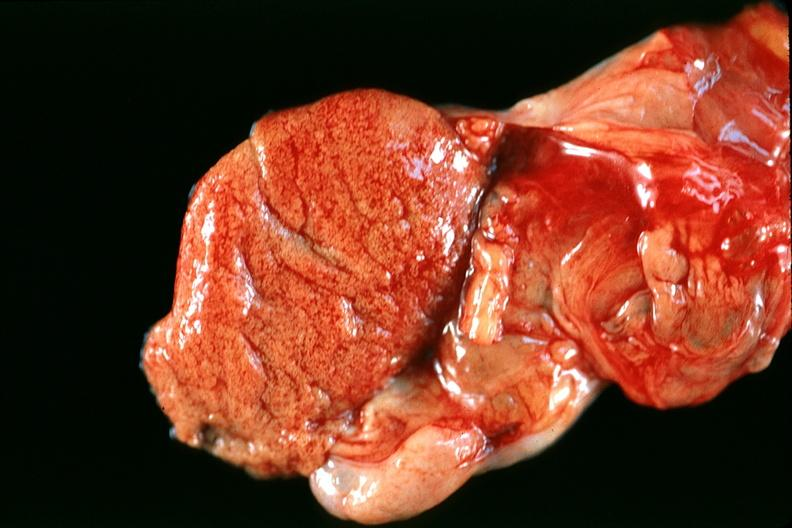what is present?
Answer the question using a single word or phrase. Male reproductive 